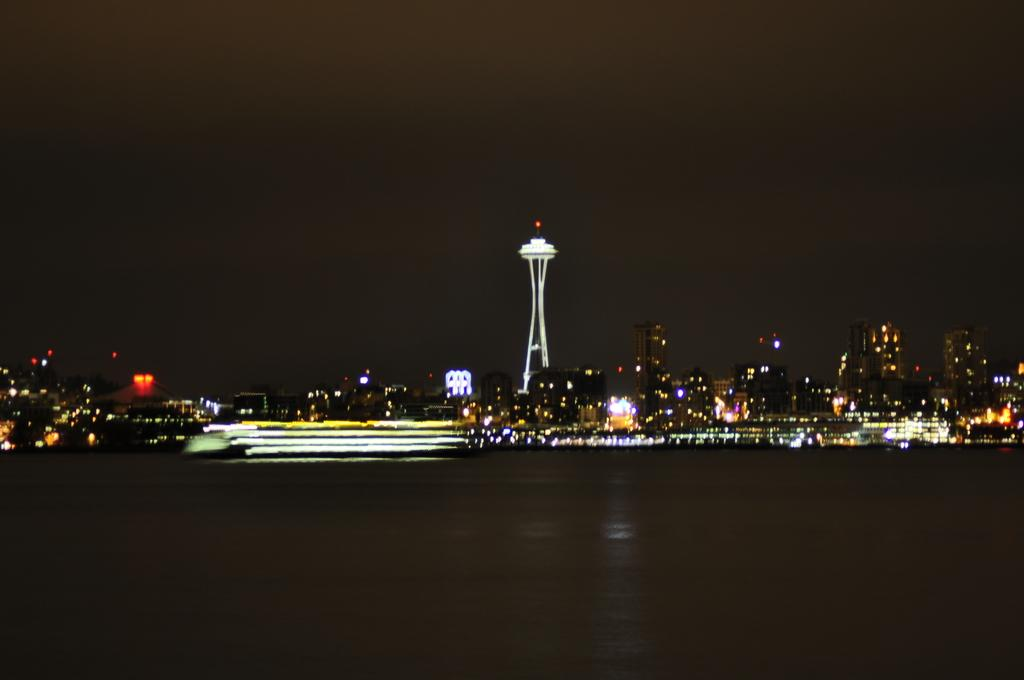What type of structures can be seen in the image? There are buildings, towers, and skyscrapers in the image. What type of lighting is present in the image? Electric lights are visible in the image. What natural element can be seen in the image? There is water visible in the image. What part of the natural environment is visible in the image? The sky is visible in the image. What type of dust can be seen on the base of the skyscraper in the image? There is no dust visible on the base of the skyscraper in the image, nor is there a base mentioned in the facts provided. 